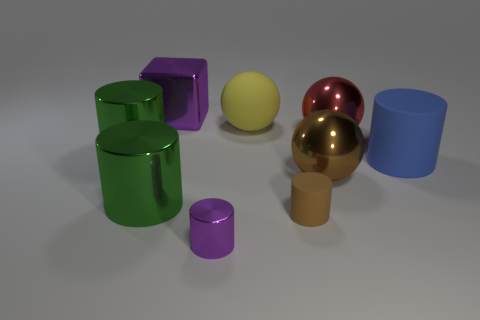What is the material of the tiny cylinder that is the same color as the large block?
Offer a terse response. Metal. The big rubber object that is the same shape as the tiny purple thing is what color?
Offer a terse response. Blue. The matte object that is behind the tiny brown rubber thing and right of the big yellow thing has what shape?
Provide a short and direct response. Cylinder. Is the material of the purple object on the right side of the large cube the same as the big blue cylinder?
Ensure brevity in your answer.  No. What color is the rubber object that is the same size as the purple metallic cylinder?
Keep it short and to the point. Brown. Is there a big metallic object of the same color as the tiny shiny thing?
Make the answer very short. Yes. What size is the purple cylinder that is made of the same material as the large red ball?
Give a very brief answer. Small. What size is the metal cylinder that is the same color as the metallic cube?
Give a very brief answer. Small. How many other things are there of the same size as the purple cube?
Your answer should be compact. 6. What is the sphere to the left of the small matte cylinder made of?
Your answer should be compact. Rubber. 